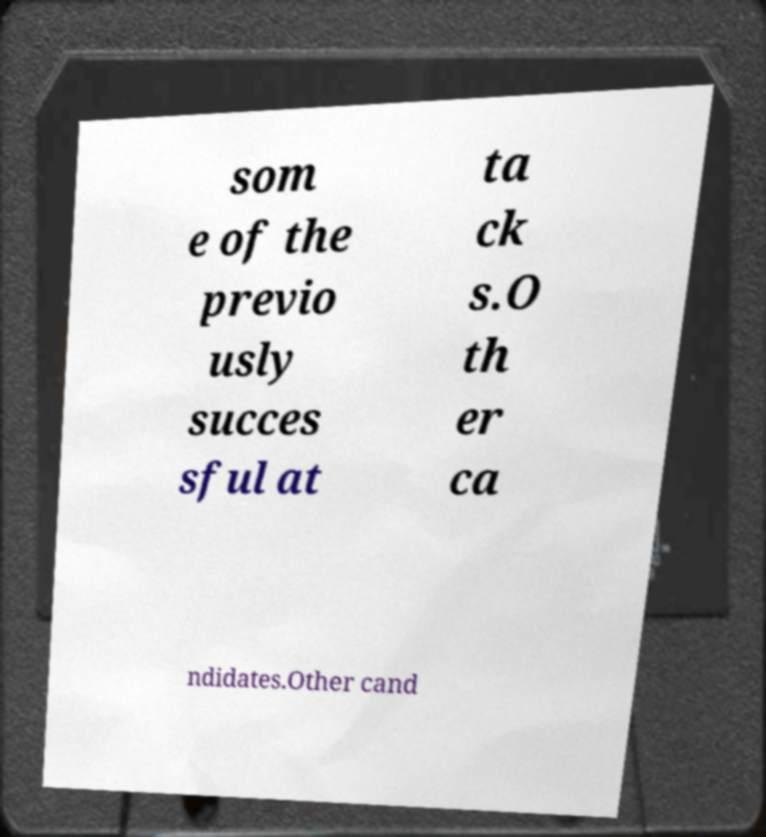Can you read and provide the text displayed in the image?This photo seems to have some interesting text. Can you extract and type it out for me? som e of the previo usly succes sful at ta ck s.O th er ca ndidates.Other cand 